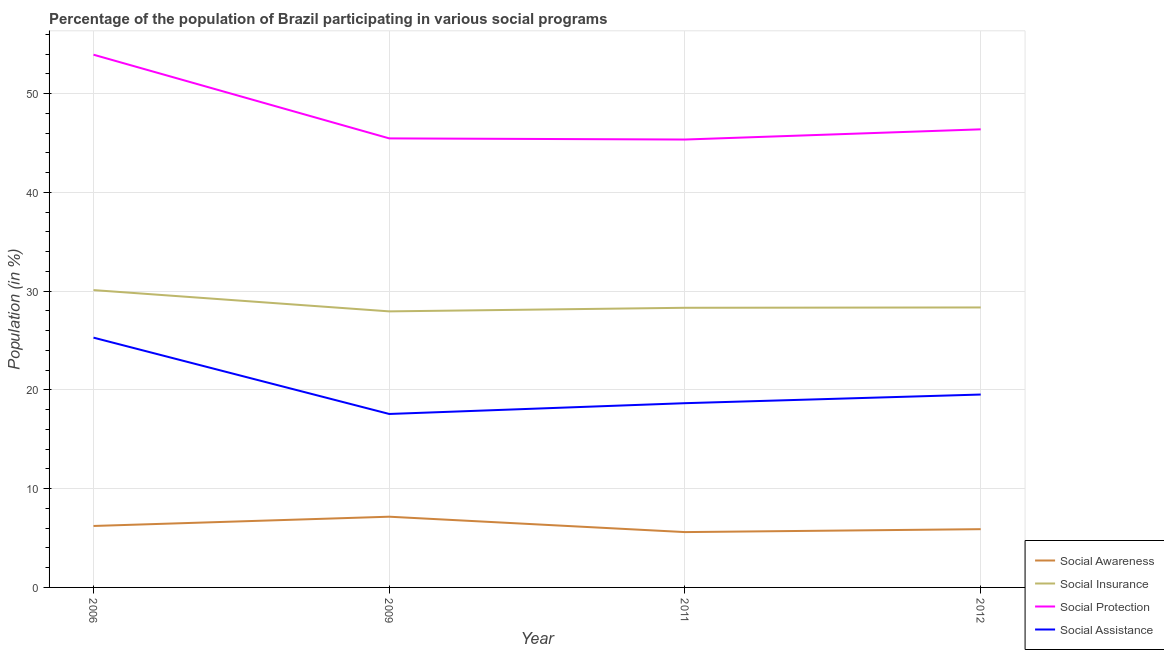Does the line corresponding to participation of population in social awareness programs intersect with the line corresponding to participation of population in social protection programs?
Keep it short and to the point. No. What is the participation of population in social awareness programs in 2011?
Keep it short and to the point. 5.6. Across all years, what is the maximum participation of population in social assistance programs?
Offer a very short reply. 25.29. Across all years, what is the minimum participation of population in social insurance programs?
Ensure brevity in your answer.  27.95. What is the total participation of population in social insurance programs in the graph?
Your answer should be compact. 114.7. What is the difference between the participation of population in social awareness programs in 2009 and that in 2011?
Provide a succinct answer. 1.56. What is the difference between the participation of population in social insurance programs in 2009 and the participation of population in social protection programs in 2006?
Make the answer very short. -25.99. What is the average participation of population in social awareness programs per year?
Keep it short and to the point. 6.22. In the year 2011, what is the difference between the participation of population in social awareness programs and participation of population in social assistance programs?
Provide a succinct answer. -13.05. In how many years, is the participation of population in social insurance programs greater than 4 %?
Keep it short and to the point. 4. What is the ratio of the participation of population in social insurance programs in 2009 to that in 2011?
Offer a terse response. 0.99. What is the difference between the highest and the second highest participation of population in social awareness programs?
Offer a very short reply. 0.94. What is the difference between the highest and the lowest participation of population in social insurance programs?
Your response must be concise. 2.15. Does the participation of population in social protection programs monotonically increase over the years?
Your answer should be very brief. No. Is the participation of population in social protection programs strictly less than the participation of population in social assistance programs over the years?
Offer a terse response. No. How many lines are there?
Offer a very short reply. 4. Where does the legend appear in the graph?
Keep it short and to the point. Bottom right. How many legend labels are there?
Provide a short and direct response. 4. How are the legend labels stacked?
Make the answer very short. Vertical. What is the title of the graph?
Your answer should be compact. Percentage of the population of Brazil participating in various social programs . What is the Population (in %) in Social Awareness in 2006?
Provide a short and direct response. 6.22. What is the Population (in %) in Social Insurance in 2006?
Provide a succinct answer. 30.1. What is the Population (in %) in Social Protection in 2006?
Make the answer very short. 53.93. What is the Population (in %) in Social Assistance in 2006?
Offer a terse response. 25.29. What is the Population (in %) of Social Awareness in 2009?
Offer a terse response. 7.16. What is the Population (in %) in Social Insurance in 2009?
Give a very brief answer. 27.95. What is the Population (in %) of Social Protection in 2009?
Keep it short and to the point. 45.46. What is the Population (in %) in Social Assistance in 2009?
Your answer should be very brief. 17.56. What is the Population (in %) of Social Awareness in 2011?
Your answer should be compact. 5.6. What is the Population (in %) in Social Insurance in 2011?
Your answer should be compact. 28.31. What is the Population (in %) of Social Protection in 2011?
Your answer should be compact. 45.34. What is the Population (in %) of Social Assistance in 2011?
Provide a short and direct response. 18.65. What is the Population (in %) of Social Awareness in 2012?
Ensure brevity in your answer.  5.9. What is the Population (in %) in Social Insurance in 2012?
Provide a short and direct response. 28.34. What is the Population (in %) of Social Protection in 2012?
Ensure brevity in your answer.  46.38. What is the Population (in %) of Social Assistance in 2012?
Offer a very short reply. 19.53. Across all years, what is the maximum Population (in %) in Social Awareness?
Your response must be concise. 7.16. Across all years, what is the maximum Population (in %) of Social Insurance?
Ensure brevity in your answer.  30.1. Across all years, what is the maximum Population (in %) in Social Protection?
Offer a terse response. 53.93. Across all years, what is the maximum Population (in %) in Social Assistance?
Keep it short and to the point. 25.29. Across all years, what is the minimum Population (in %) of Social Awareness?
Your answer should be very brief. 5.6. Across all years, what is the minimum Population (in %) in Social Insurance?
Provide a short and direct response. 27.95. Across all years, what is the minimum Population (in %) of Social Protection?
Your answer should be very brief. 45.34. Across all years, what is the minimum Population (in %) of Social Assistance?
Offer a terse response. 17.56. What is the total Population (in %) of Social Awareness in the graph?
Your response must be concise. 24.88. What is the total Population (in %) of Social Insurance in the graph?
Provide a short and direct response. 114.7. What is the total Population (in %) of Social Protection in the graph?
Make the answer very short. 191.11. What is the total Population (in %) of Social Assistance in the graph?
Offer a terse response. 81.03. What is the difference between the Population (in %) of Social Awareness in 2006 and that in 2009?
Make the answer very short. -0.94. What is the difference between the Population (in %) of Social Insurance in 2006 and that in 2009?
Ensure brevity in your answer.  2.15. What is the difference between the Population (in %) in Social Protection in 2006 and that in 2009?
Make the answer very short. 8.47. What is the difference between the Population (in %) in Social Assistance in 2006 and that in 2009?
Your answer should be very brief. 7.73. What is the difference between the Population (in %) of Social Awareness in 2006 and that in 2011?
Your answer should be compact. 0.62. What is the difference between the Population (in %) in Social Insurance in 2006 and that in 2011?
Provide a succinct answer. 1.79. What is the difference between the Population (in %) in Social Protection in 2006 and that in 2011?
Offer a terse response. 8.59. What is the difference between the Population (in %) of Social Assistance in 2006 and that in 2011?
Your response must be concise. 6.64. What is the difference between the Population (in %) in Social Awareness in 2006 and that in 2012?
Give a very brief answer. 0.32. What is the difference between the Population (in %) of Social Insurance in 2006 and that in 2012?
Your answer should be very brief. 1.76. What is the difference between the Population (in %) in Social Protection in 2006 and that in 2012?
Provide a succinct answer. 7.56. What is the difference between the Population (in %) in Social Assistance in 2006 and that in 2012?
Your response must be concise. 5.76. What is the difference between the Population (in %) of Social Awareness in 2009 and that in 2011?
Give a very brief answer. 1.56. What is the difference between the Population (in %) of Social Insurance in 2009 and that in 2011?
Ensure brevity in your answer.  -0.36. What is the difference between the Population (in %) of Social Protection in 2009 and that in 2011?
Provide a succinct answer. 0.12. What is the difference between the Population (in %) of Social Assistance in 2009 and that in 2011?
Your answer should be compact. -1.09. What is the difference between the Population (in %) in Social Awareness in 2009 and that in 2012?
Your response must be concise. 1.26. What is the difference between the Population (in %) of Social Insurance in 2009 and that in 2012?
Offer a very short reply. -0.4. What is the difference between the Population (in %) of Social Protection in 2009 and that in 2012?
Your answer should be very brief. -0.92. What is the difference between the Population (in %) in Social Assistance in 2009 and that in 2012?
Provide a succinct answer. -1.97. What is the difference between the Population (in %) in Social Awareness in 2011 and that in 2012?
Make the answer very short. -0.3. What is the difference between the Population (in %) in Social Insurance in 2011 and that in 2012?
Your answer should be compact. -0.03. What is the difference between the Population (in %) of Social Protection in 2011 and that in 2012?
Provide a short and direct response. -1.03. What is the difference between the Population (in %) in Social Assistance in 2011 and that in 2012?
Offer a terse response. -0.88. What is the difference between the Population (in %) in Social Awareness in 2006 and the Population (in %) in Social Insurance in 2009?
Provide a succinct answer. -21.73. What is the difference between the Population (in %) of Social Awareness in 2006 and the Population (in %) of Social Protection in 2009?
Your answer should be very brief. -39.24. What is the difference between the Population (in %) in Social Awareness in 2006 and the Population (in %) in Social Assistance in 2009?
Provide a short and direct response. -11.34. What is the difference between the Population (in %) of Social Insurance in 2006 and the Population (in %) of Social Protection in 2009?
Keep it short and to the point. -15.36. What is the difference between the Population (in %) in Social Insurance in 2006 and the Population (in %) in Social Assistance in 2009?
Your answer should be very brief. 12.54. What is the difference between the Population (in %) of Social Protection in 2006 and the Population (in %) of Social Assistance in 2009?
Your response must be concise. 36.37. What is the difference between the Population (in %) in Social Awareness in 2006 and the Population (in %) in Social Insurance in 2011?
Ensure brevity in your answer.  -22.09. What is the difference between the Population (in %) in Social Awareness in 2006 and the Population (in %) in Social Protection in 2011?
Offer a terse response. -39.12. What is the difference between the Population (in %) of Social Awareness in 2006 and the Population (in %) of Social Assistance in 2011?
Make the answer very short. -12.43. What is the difference between the Population (in %) of Social Insurance in 2006 and the Population (in %) of Social Protection in 2011?
Ensure brevity in your answer.  -15.24. What is the difference between the Population (in %) in Social Insurance in 2006 and the Population (in %) in Social Assistance in 2011?
Provide a succinct answer. 11.45. What is the difference between the Population (in %) of Social Protection in 2006 and the Population (in %) of Social Assistance in 2011?
Make the answer very short. 35.28. What is the difference between the Population (in %) of Social Awareness in 2006 and the Population (in %) of Social Insurance in 2012?
Ensure brevity in your answer.  -22.12. What is the difference between the Population (in %) of Social Awareness in 2006 and the Population (in %) of Social Protection in 2012?
Your response must be concise. -40.16. What is the difference between the Population (in %) of Social Awareness in 2006 and the Population (in %) of Social Assistance in 2012?
Offer a very short reply. -13.31. What is the difference between the Population (in %) in Social Insurance in 2006 and the Population (in %) in Social Protection in 2012?
Provide a short and direct response. -16.28. What is the difference between the Population (in %) of Social Insurance in 2006 and the Population (in %) of Social Assistance in 2012?
Your answer should be very brief. 10.57. What is the difference between the Population (in %) of Social Protection in 2006 and the Population (in %) of Social Assistance in 2012?
Your answer should be compact. 34.4. What is the difference between the Population (in %) in Social Awareness in 2009 and the Population (in %) in Social Insurance in 2011?
Offer a terse response. -21.15. What is the difference between the Population (in %) in Social Awareness in 2009 and the Population (in %) in Social Protection in 2011?
Provide a succinct answer. -38.18. What is the difference between the Population (in %) of Social Awareness in 2009 and the Population (in %) of Social Assistance in 2011?
Your answer should be very brief. -11.49. What is the difference between the Population (in %) of Social Insurance in 2009 and the Population (in %) of Social Protection in 2011?
Offer a terse response. -17.4. What is the difference between the Population (in %) of Social Insurance in 2009 and the Population (in %) of Social Assistance in 2011?
Give a very brief answer. 9.29. What is the difference between the Population (in %) of Social Protection in 2009 and the Population (in %) of Social Assistance in 2011?
Keep it short and to the point. 26.81. What is the difference between the Population (in %) in Social Awareness in 2009 and the Population (in %) in Social Insurance in 2012?
Keep it short and to the point. -21.18. What is the difference between the Population (in %) in Social Awareness in 2009 and the Population (in %) in Social Protection in 2012?
Offer a terse response. -39.22. What is the difference between the Population (in %) of Social Awareness in 2009 and the Population (in %) of Social Assistance in 2012?
Make the answer very short. -12.37. What is the difference between the Population (in %) in Social Insurance in 2009 and the Population (in %) in Social Protection in 2012?
Offer a terse response. -18.43. What is the difference between the Population (in %) in Social Insurance in 2009 and the Population (in %) in Social Assistance in 2012?
Keep it short and to the point. 8.42. What is the difference between the Population (in %) of Social Protection in 2009 and the Population (in %) of Social Assistance in 2012?
Provide a succinct answer. 25.93. What is the difference between the Population (in %) of Social Awareness in 2011 and the Population (in %) of Social Insurance in 2012?
Your answer should be compact. -22.74. What is the difference between the Population (in %) of Social Awareness in 2011 and the Population (in %) of Social Protection in 2012?
Give a very brief answer. -40.77. What is the difference between the Population (in %) in Social Awareness in 2011 and the Population (in %) in Social Assistance in 2012?
Provide a succinct answer. -13.93. What is the difference between the Population (in %) of Social Insurance in 2011 and the Population (in %) of Social Protection in 2012?
Ensure brevity in your answer.  -18.07. What is the difference between the Population (in %) in Social Insurance in 2011 and the Population (in %) in Social Assistance in 2012?
Your answer should be compact. 8.78. What is the difference between the Population (in %) in Social Protection in 2011 and the Population (in %) in Social Assistance in 2012?
Offer a terse response. 25.82. What is the average Population (in %) in Social Awareness per year?
Your answer should be very brief. 6.22. What is the average Population (in %) of Social Insurance per year?
Give a very brief answer. 28.68. What is the average Population (in %) in Social Protection per year?
Give a very brief answer. 47.78. What is the average Population (in %) of Social Assistance per year?
Your answer should be very brief. 20.26. In the year 2006, what is the difference between the Population (in %) in Social Awareness and Population (in %) in Social Insurance?
Keep it short and to the point. -23.88. In the year 2006, what is the difference between the Population (in %) in Social Awareness and Population (in %) in Social Protection?
Provide a short and direct response. -47.71. In the year 2006, what is the difference between the Population (in %) in Social Awareness and Population (in %) in Social Assistance?
Offer a terse response. -19.07. In the year 2006, what is the difference between the Population (in %) of Social Insurance and Population (in %) of Social Protection?
Provide a succinct answer. -23.83. In the year 2006, what is the difference between the Population (in %) in Social Insurance and Population (in %) in Social Assistance?
Your answer should be compact. 4.81. In the year 2006, what is the difference between the Population (in %) of Social Protection and Population (in %) of Social Assistance?
Your answer should be compact. 28.64. In the year 2009, what is the difference between the Population (in %) in Social Awareness and Population (in %) in Social Insurance?
Your answer should be very brief. -20.79. In the year 2009, what is the difference between the Population (in %) of Social Awareness and Population (in %) of Social Protection?
Provide a short and direct response. -38.3. In the year 2009, what is the difference between the Population (in %) in Social Awareness and Population (in %) in Social Assistance?
Ensure brevity in your answer.  -10.4. In the year 2009, what is the difference between the Population (in %) in Social Insurance and Population (in %) in Social Protection?
Provide a short and direct response. -17.51. In the year 2009, what is the difference between the Population (in %) in Social Insurance and Population (in %) in Social Assistance?
Give a very brief answer. 10.39. In the year 2009, what is the difference between the Population (in %) in Social Protection and Population (in %) in Social Assistance?
Your response must be concise. 27.9. In the year 2011, what is the difference between the Population (in %) of Social Awareness and Population (in %) of Social Insurance?
Your answer should be very brief. -22.71. In the year 2011, what is the difference between the Population (in %) in Social Awareness and Population (in %) in Social Protection?
Give a very brief answer. -39.74. In the year 2011, what is the difference between the Population (in %) in Social Awareness and Population (in %) in Social Assistance?
Offer a very short reply. -13.05. In the year 2011, what is the difference between the Population (in %) in Social Insurance and Population (in %) in Social Protection?
Ensure brevity in your answer.  -17.03. In the year 2011, what is the difference between the Population (in %) in Social Insurance and Population (in %) in Social Assistance?
Provide a short and direct response. 9.66. In the year 2011, what is the difference between the Population (in %) of Social Protection and Population (in %) of Social Assistance?
Offer a terse response. 26.69. In the year 2012, what is the difference between the Population (in %) in Social Awareness and Population (in %) in Social Insurance?
Make the answer very short. -22.45. In the year 2012, what is the difference between the Population (in %) of Social Awareness and Population (in %) of Social Protection?
Your response must be concise. -40.48. In the year 2012, what is the difference between the Population (in %) of Social Awareness and Population (in %) of Social Assistance?
Give a very brief answer. -13.63. In the year 2012, what is the difference between the Population (in %) in Social Insurance and Population (in %) in Social Protection?
Your response must be concise. -18.03. In the year 2012, what is the difference between the Population (in %) in Social Insurance and Population (in %) in Social Assistance?
Your response must be concise. 8.82. In the year 2012, what is the difference between the Population (in %) in Social Protection and Population (in %) in Social Assistance?
Your response must be concise. 26.85. What is the ratio of the Population (in %) in Social Awareness in 2006 to that in 2009?
Offer a terse response. 0.87. What is the ratio of the Population (in %) in Social Insurance in 2006 to that in 2009?
Offer a very short reply. 1.08. What is the ratio of the Population (in %) of Social Protection in 2006 to that in 2009?
Make the answer very short. 1.19. What is the ratio of the Population (in %) in Social Assistance in 2006 to that in 2009?
Provide a short and direct response. 1.44. What is the ratio of the Population (in %) in Social Awareness in 2006 to that in 2011?
Your response must be concise. 1.11. What is the ratio of the Population (in %) in Social Insurance in 2006 to that in 2011?
Provide a succinct answer. 1.06. What is the ratio of the Population (in %) of Social Protection in 2006 to that in 2011?
Your answer should be very brief. 1.19. What is the ratio of the Population (in %) in Social Assistance in 2006 to that in 2011?
Offer a very short reply. 1.36. What is the ratio of the Population (in %) of Social Awareness in 2006 to that in 2012?
Offer a terse response. 1.05. What is the ratio of the Population (in %) in Social Insurance in 2006 to that in 2012?
Offer a very short reply. 1.06. What is the ratio of the Population (in %) in Social Protection in 2006 to that in 2012?
Keep it short and to the point. 1.16. What is the ratio of the Population (in %) of Social Assistance in 2006 to that in 2012?
Provide a short and direct response. 1.29. What is the ratio of the Population (in %) in Social Awareness in 2009 to that in 2011?
Provide a short and direct response. 1.28. What is the ratio of the Population (in %) of Social Insurance in 2009 to that in 2011?
Make the answer very short. 0.99. What is the ratio of the Population (in %) of Social Assistance in 2009 to that in 2011?
Offer a very short reply. 0.94. What is the ratio of the Population (in %) in Social Awareness in 2009 to that in 2012?
Offer a very short reply. 1.21. What is the ratio of the Population (in %) in Social Protection in 2009 to that in 2012?
Provide a short and direct response. 0.98. What is the ratio of the Population (in %) of Social Assistance in 2009 to that in 2012?
Provide a short and direct response. 0.9. What is the ratio of the Population (in %) in Social Awareness in 2011 to that in 2012?
Offer a very short reply. 0.95. What is the ratio of the Population (in %) of Social Protection in 2011 to that in 2012?
Give a very brief answer. 0.98. What is the ratio of the Population (in %) of Social Assistance in 2011 to that in 2012?
Your response must be concise. 0.96. What is the difference between the highest and the second highest Population (in %) of Social Awareness?
Provide a succinct answer. 0.94. What is the difference between the highest and the second highest Population (in %) of Social Insurance?
Offer a terse response. 1.76. What is the difference between the highest and the second highest Population (in %) in Social Protection?
Make the answer very short. 7.56. What is the difference between the highest and the second highest Population (in %) of Social Assistance?
Offer a very short reply. 5.76. What is the difference between the highest and the lowest Population (in %) of Social Awareness?
Make the answer very short. 1.56. What is the difference between the highest and the lowest Population (in %) in Social Insurance?
Your answer should be very brief. 2.15. What is the difference between the highest and the lowest Population (in %) of Social Protection?
Your answer should be compact. 8.59. What is the difference between the highest and the lowest Population (in %) of Social Assistance?
Give a very brief answer. 7.73. 